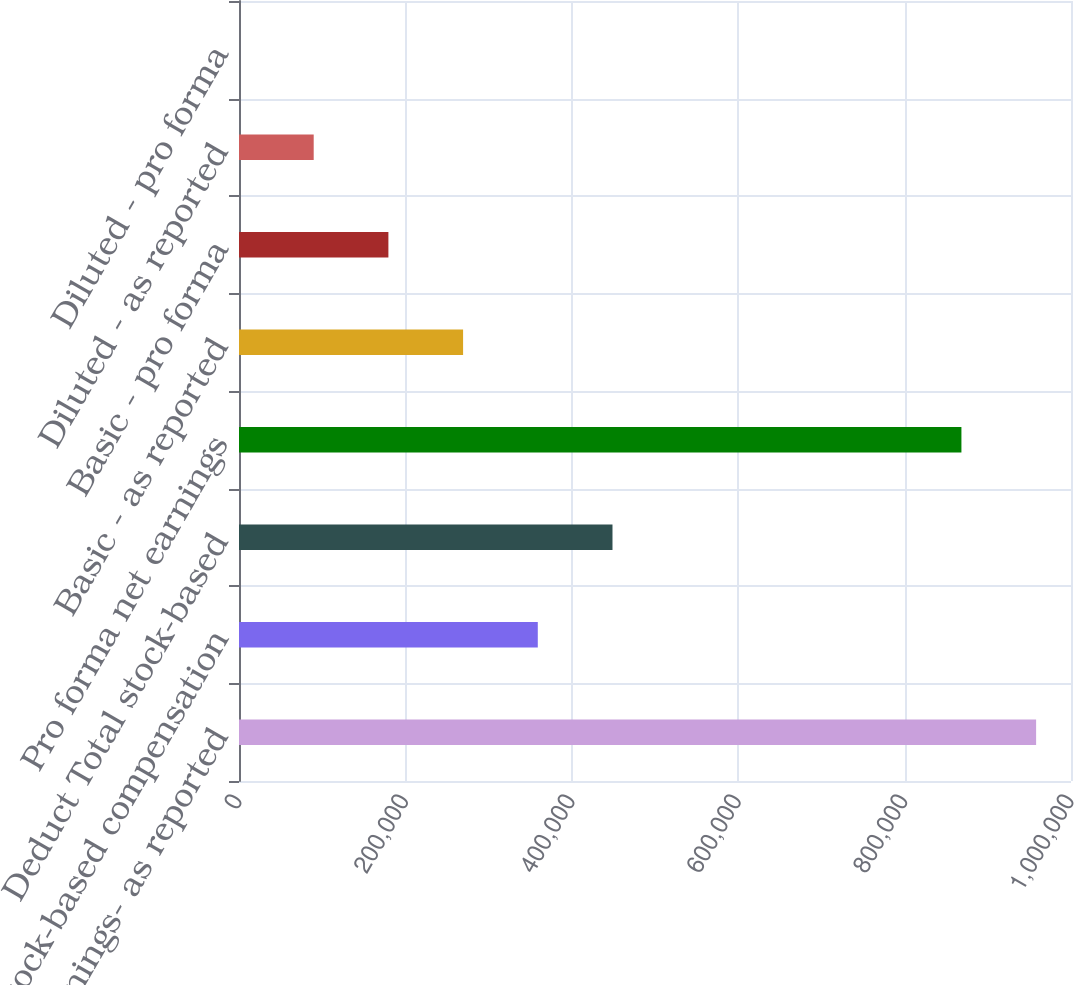<chart> <loc_0><loc_0><loc_500><loc_500><bar_chart><fcel>Net earnings- as reported<fcel>Add Stock-based compensation<fcel>Deduct Total stock-based<fcel>Pro forma net earnings<fcel>Basic - as reported<fcel>Basic - pro forma<fcel>Diluted - as reported<fcel>Diluted - pro forma<nl><fcel>958079<fcel>359122<fcel>448901<fcel>868299<fcel>269342<fcel>179562<fcel>89782.4<fcel>2.67<nl></chart> 